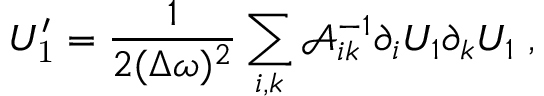<formula> <loc_0><loc_0><loc_500><loc_500>U _ { 1 } ^ { \prime } = \frac { 1 } { 2 ( \Delta \omega ) ^ { 2 } } \sum _ { i , k } \mathcal { A } _ { i k } ^ { - 1 } \partial _ { i } U _ { 1 } \partial _ { k } U _ { 1 } \, ,</formula> 